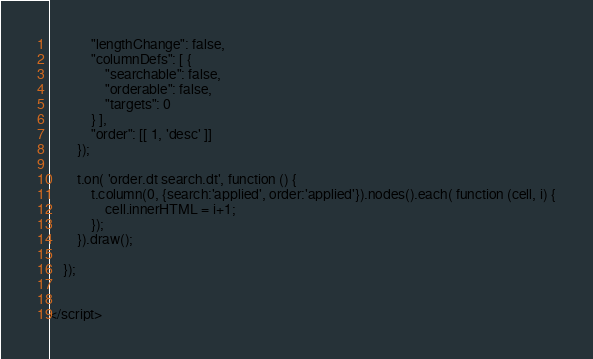Convert code to text. <code><loc_0><loc_0><loc_500><loc_500><_PHP_>            "lengthChange": false,
            "columnDefs": [ {
                "searchable": false,
                "orderable": false,
                "targets": 0
            } ],
            "order": [[ 1, 'desc' ]]
        });
    
        t.on( 'order.dt search.dt', function () {
            t.column(0, {search:'applied', order:'applied'}).nodes().each( function (cell, i) {
                cell.innerHTML = i+1;
            });
        }).draw();

    });


</script></code> 